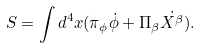<formula> <loc_0><loc_0><loc_500><loc_500>S = \int d ^ { 4 } x ( \pi _ { \phi } \dot { \phi } + \Pi _ { \beta } \dot { X ^ { \beta } } ) .</formula> 